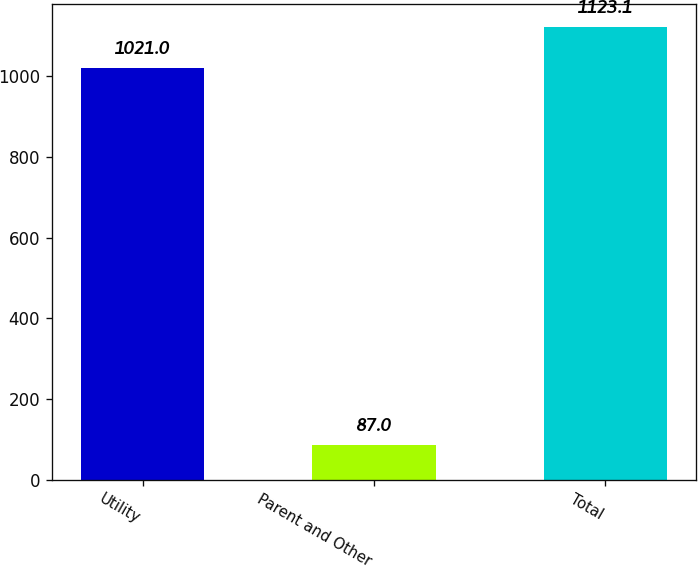Convert chart. <chart><loc_0><loc_0><loc_500><loc_500><bar_chart><fcel>Utility<fcel>Parent and Other<fcel>Total<nl><fcel>1021<fcel>87<fcel>1123.1<nl></chart> 